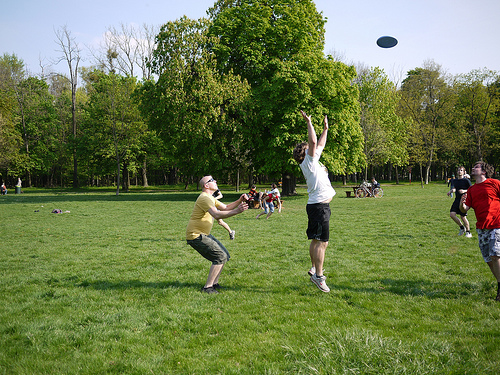Do the shorts have black color? Yes, the shorts worn by one of the individuals do have black color. 